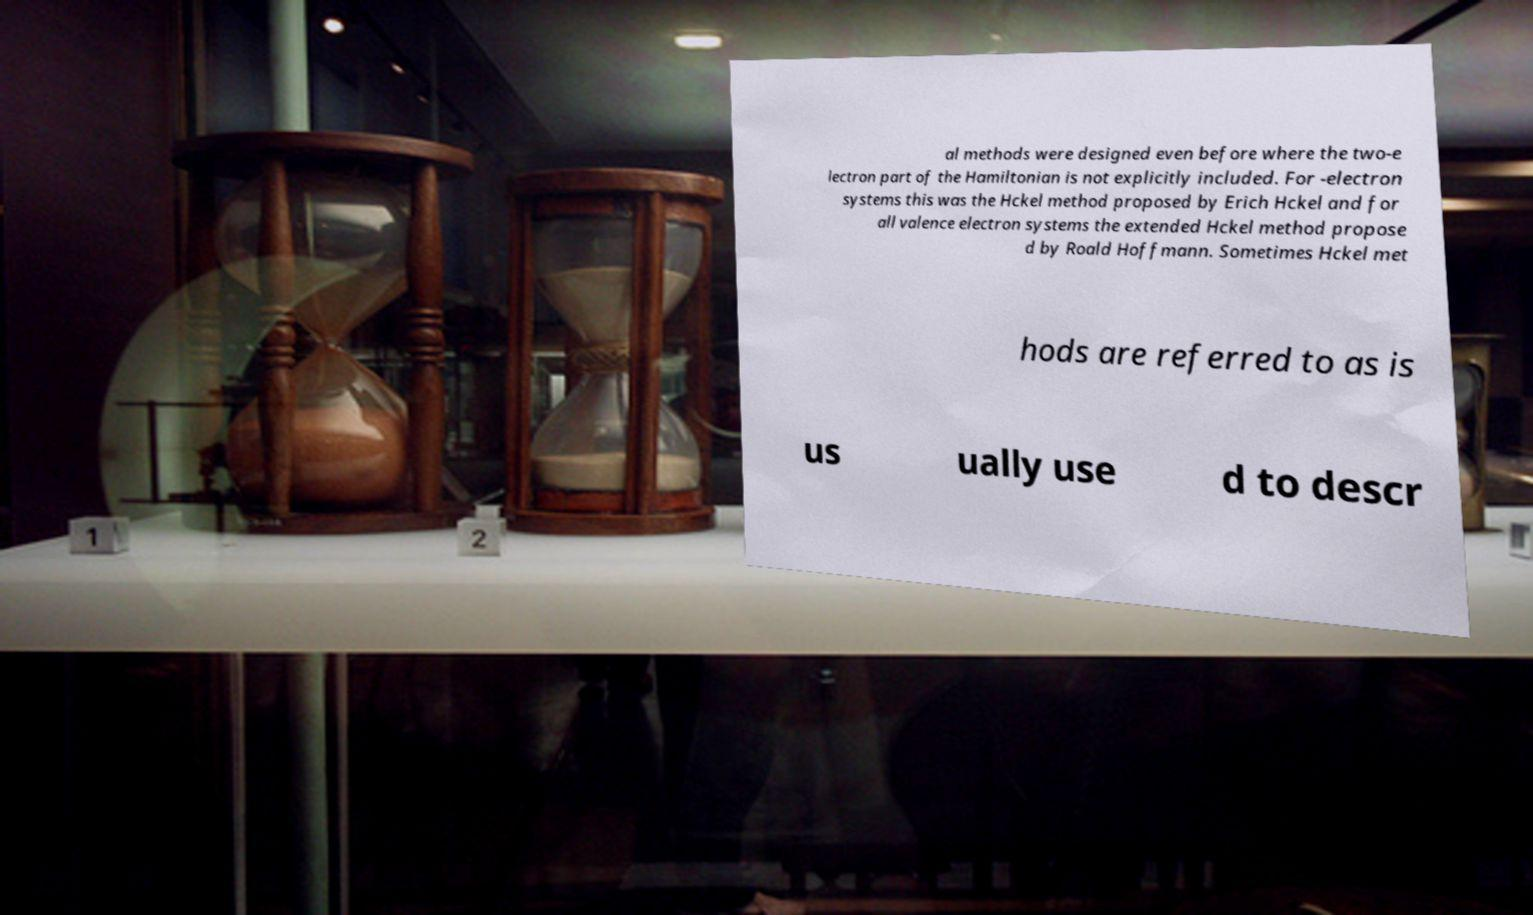Please identify and transcribe the text found in this image. al methods were designed even before where the two-e lectron part of the Hamiltonian is not explicitly included. For -electron systems this was the Hckel method proposed by Erich Hckel and for all valence electron systems the extended Hckel method propose d by Roald Hoffmann. Sometimes Hckel met hods are referred to as is us ually use d to descr 